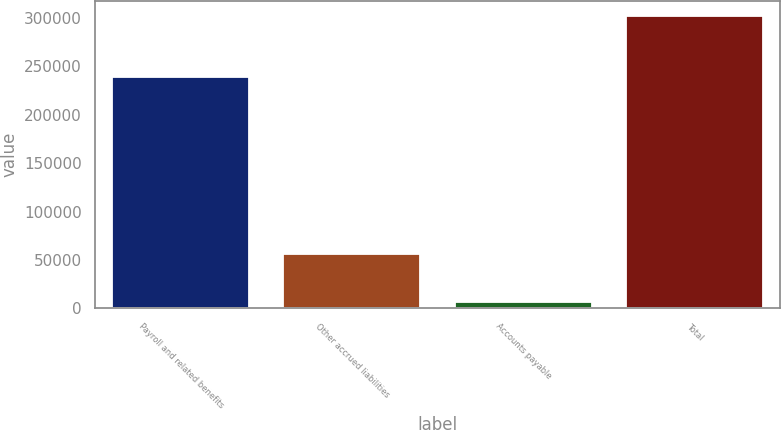Convert chart. <chart><loc_0><loc_0><loc_500><loc_500><bar_chart><fcel>Payroll and related benefits<fcel>Other accrued liabilities<fcel>Accounts payable<fcel>Total<nl><fcel>238691<fcel>56529<fcel>6956<fcel>302176<nl></chart> 